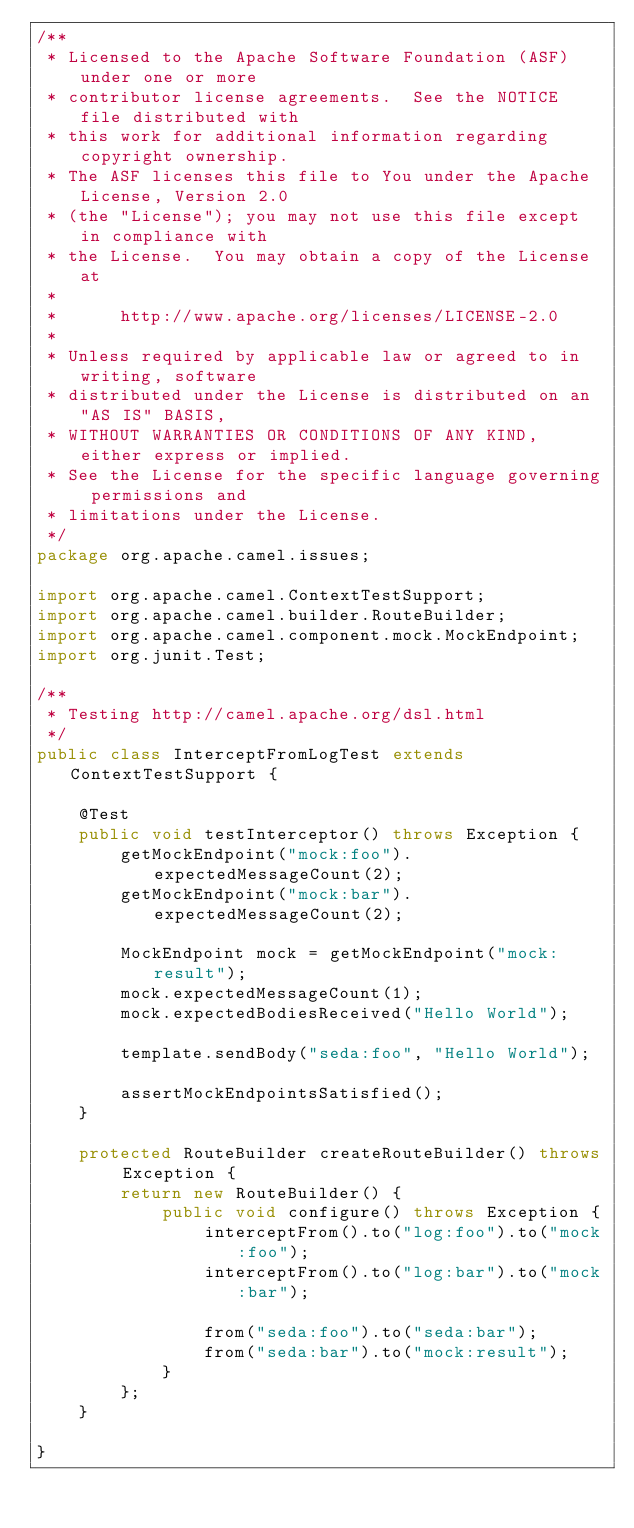Convert code to text. <code><loc_0><loc_0><loc_500><loc_500><_Java_>/**
 * Licensed to the Apache Software Foundation (ASF) under one or more
 * contributor license agreements.  See the NOTICE file distributed with
 * this work for additional information regarding copyright ownership.
 * The ASF licenses this file to You under the Apache License, Version 2.0
 * (the "License"); you may not use this file except in compliance with
 * the License.  You may obtain a copy of the License at
 *
 *      http://www.apache.org/licenses/LICENSE-2.0
 *
 * Unless required by applicable law or agreed to in writing, software
 * distributed under the License is distributed on an "AS IS" BASIS,
 * WITHOUT WARRANTIES OR CONDITIONS OF ANY KIND, either express or implied.
 * See the License for the specific language governing permissions and
 * limitations under the License.
 */
package org.apache.camel.issues;

import org.apache.camel.ContextTestSupport;
import org.apache.camel.builder.RouteBuilder;
import org.apache.camel.component.mock.MockEndpoint;
import org.junit.Test;

/**
 * Testing http://camel.apache.org/dsl.html
 */
public class InterceptFromLogTest extends ContextTestSupport {

    @Test
    public void testInterceptor() throws Exception {
        getMockEndpoint("mock:foo").expectedMessageCount(2);
        getMockEndpoint("mock:bar").expectedMessageCount(2);

        MockEndpoint mock = getMockEndpoint("mock:result");
        mock.expectedMessageCount(1);
        mock.expectedBodiesReceived("Hello World");

        template.sendBody("seda:foo", "Hello World");

        assertMockEndpointsSatisfied();
    }

    protected RouteBuilder createRouteBuilder() throws Exception {
        return new RouteBuilder() {
            public void configure() throws Exception {
                interceptFrom().to("log:foo").to("mock:foo");
                interceptFrom().to("log:bar").to("mock:bar");

                from("seda:foo").to("seda:bar");
                from("seda:bar").to("mock:result");
            }
        };
    }

}
</code> 